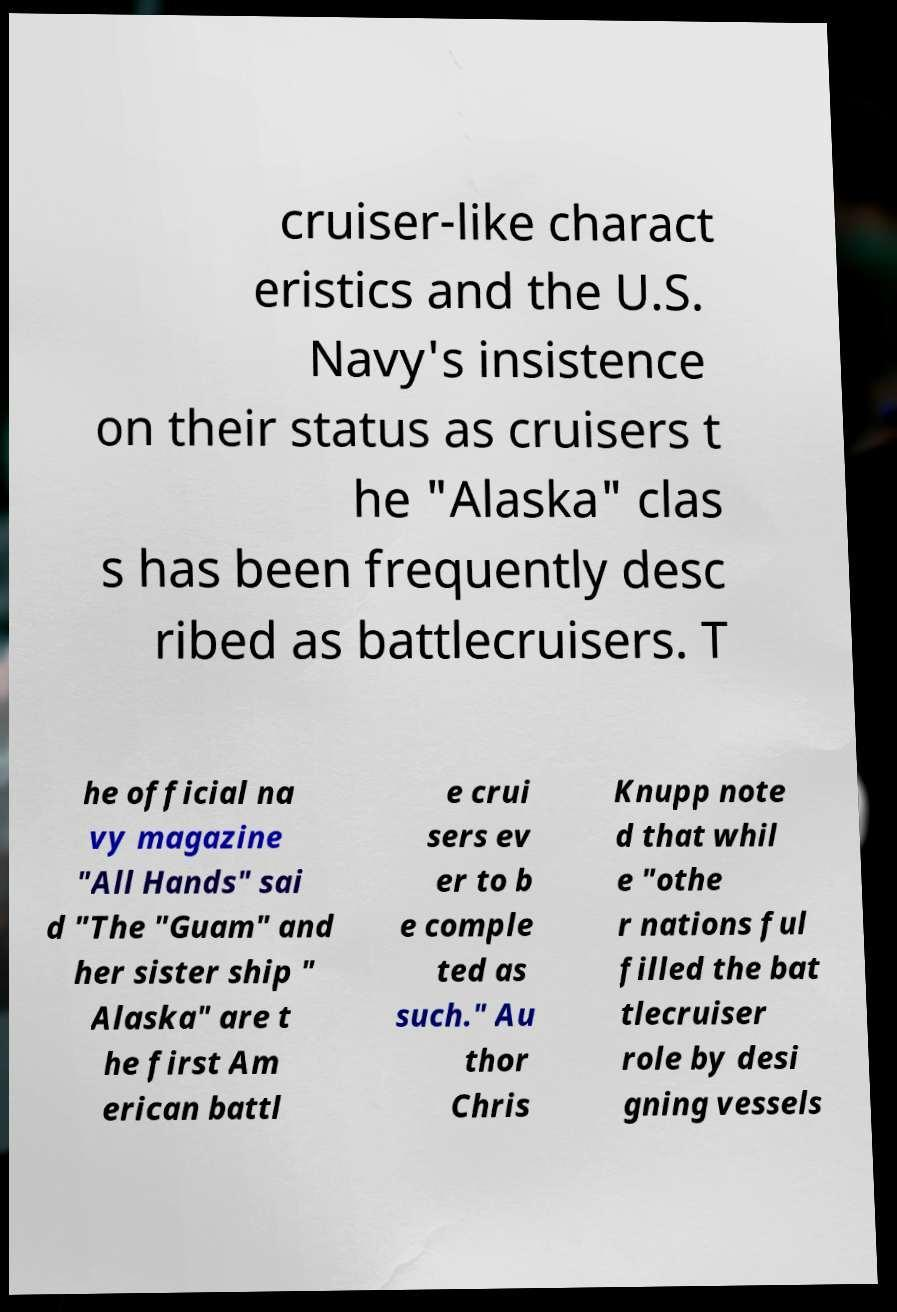What messages or text are displayed in this image? I need them in a readable, typed format. cruiser-like charact eristics and the U.S. Navy's insistence on their status as cruisers t he "Alaska" clas s has been frequently desc ribed as battlecruisers. T he official na vy magazine "All Hands" sai d "The "Guam" and her sister ship " Alaska" are t he first Am erican battl e crui sers ev er to b e comple ted as such." Au thor Chris Knupp note d that whil e "othe r nations ful filled the bat tlecruiser role by desi gning vessels 